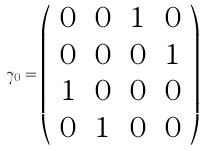<formula> <loc_0><loc_0><loc_500><loc_500>\gamma _ { 0 } = \left ( \begin{array} { c c c c } 0 & 0 & 1 & 0 \\ 0 & 0 & 0 & 1 \\ 1 & 0 & 0 & 0 \\ 0 & 1 & 0 & 0 \end{array} \right )</formula> 